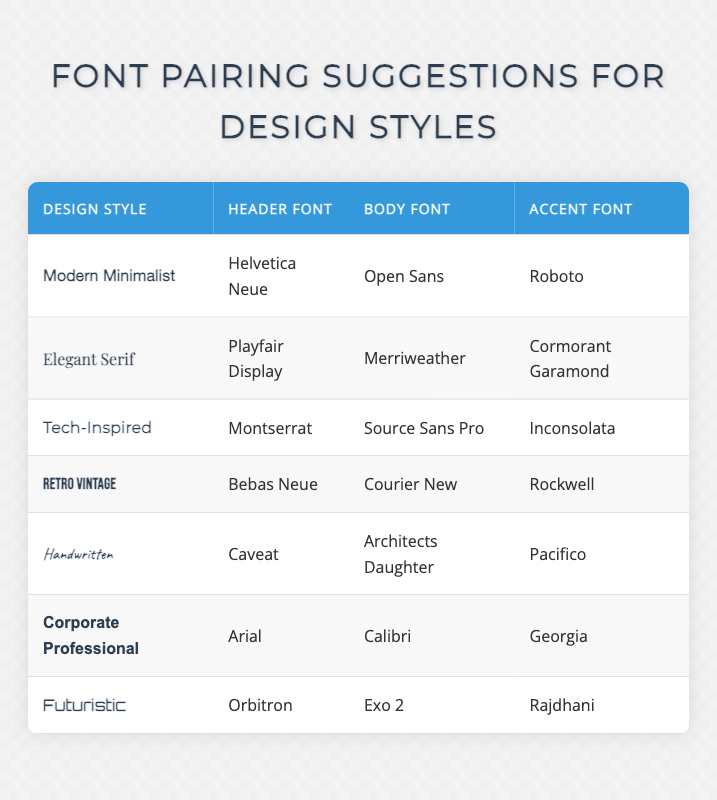What is the header font used in the Modern Minimalist design style? From the row corresponding to "Modern Minimalist" in the table, the Header Font is listed as "Helvetica Neue."
Answer: Helvetica Neue Which design style uses "Exo 2" as the body font? Looking through the table, the design style "Futuristic" has "Exo 2" listed as its Body Font.
Answer: Futuristic Is "Rockwell" used as an accent font in any design style? Checking the rows in the table, "Rockwell" is mentioned as the Accent Font for the "Retro Vintage" design style. Therefore, the answer is yes.
Answer: Yes What are the body fonts for both the Elegant Serif and the Corporate Professional design styles? The body font for "Elegant Serif" is "Merriweather," and for "Corporate Professional," it is "Calibri."
Answer: Merriweather, Calibri Which design style has the highest contrast between the header and body fonts? Evaluating the design styles, "Elegant Serif" has a distinct serif header font (Playfair Display) and a sans-serif body font (Merriweather), representing significant contrast. The same applies to "Retro Vintage" with a sans-serif header (Bebas Neue) and a monospaced body font (Courier New).
Answer: Elegant Serif and Retro Vintage What is the total number of design styles listed in the table? The table contains 7 unique design styles, counted by the number of rows under the design style heading.
Answer: 7 If you wanted to create a design style that combines the header font from Tech-Inspired and the body font from Handwritten, what fonts would that entail? The header font from "Tech-Inspired" is "Montserrat" and the body font from "Handwritten" is "Architects Daughter." Therefore, the combination would yield these two fonts if such a new style were created.
Answer: Montserrat, Architects Daughter Are there any design styles that share the same body font as a header font in another style? Yes, "Open Sans" is used as the Body Font in the "Modern Minimalist" style and could also be considered a good header font for another context, but there are no direct overlaps between header and body fonts in different styles listed in the table. The answer is no.
Answer: No 